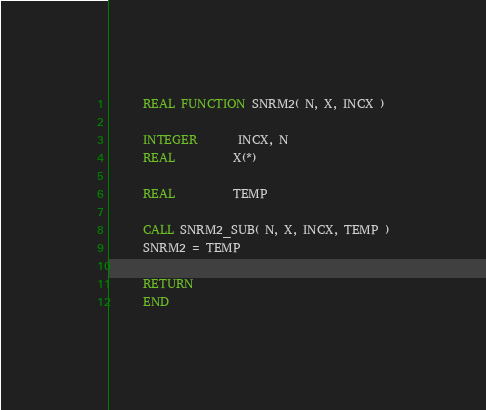<code> <loc_0><loc_0><loc_500><loc_500><_FORTRAN_>      REAL FUNCTION SNRM2( N, X, INCX )

      INTEGER       INCX, N
      REAL          X(*)

      REAL          TEMP

      CALL SNRM2_SUB( N, X, INCX, TEMP )
      SNRM2 = TEMP

      RETURN
      END
</code> 